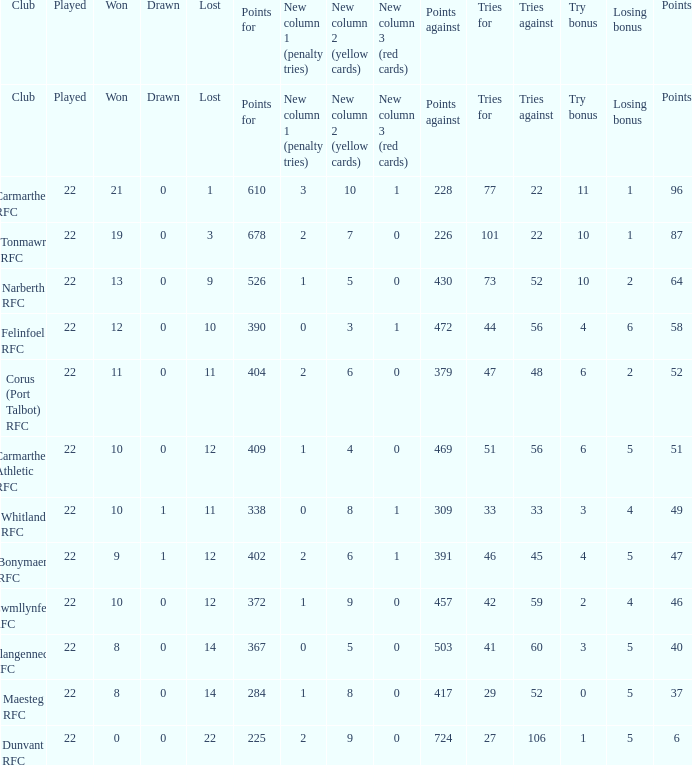Name the points against for 51 points 469.0. 